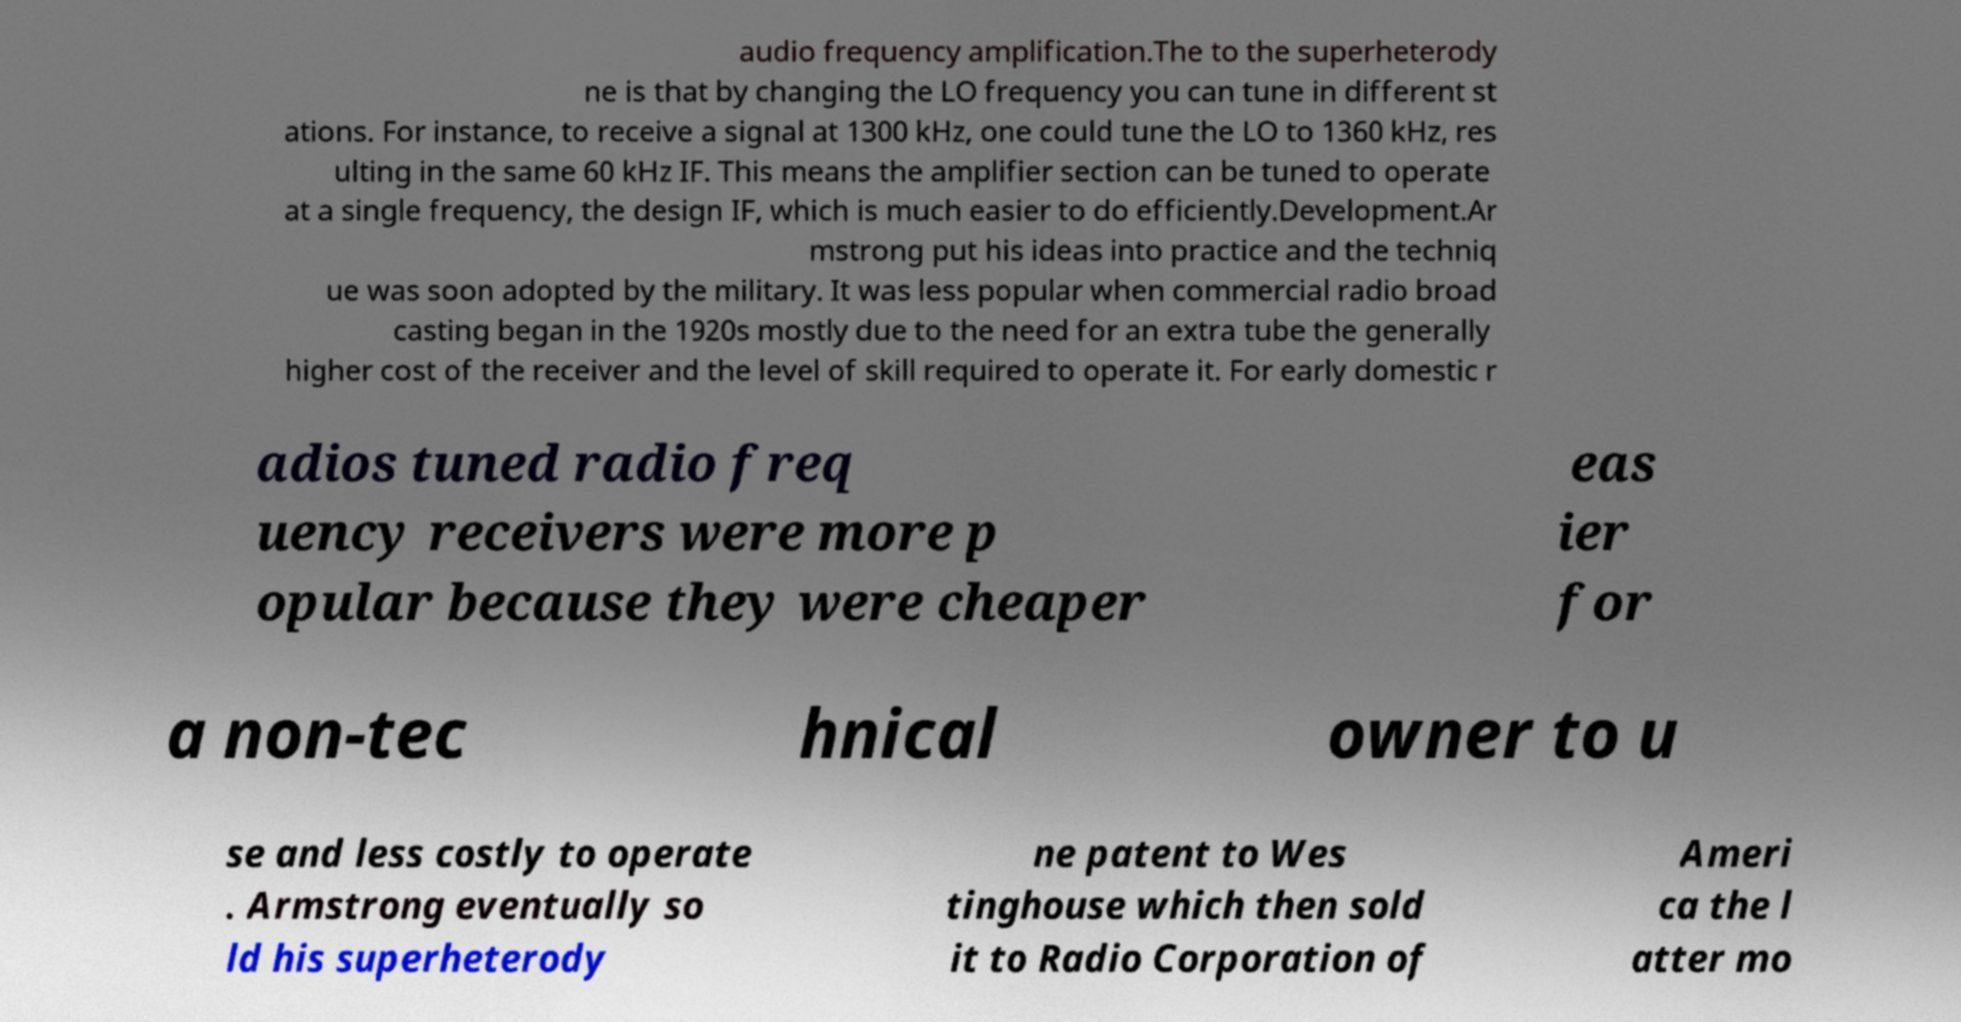Could you assist in decoding the text presented in this image and type it out clearly? audio frequency amplification.The to the superheterody ne is that by changing the LO frequency you can tune in different st ations. For instance, to receive a signal at 1300 kHz, one could tune the LO to 1360 kHz, res ulting in the same 60 kHz IF. This means the amplifier section can be tuned to operate at a single frequency, the design IF, which is much easier to do efficiently.Development.Ar mstrong put his ideas into practice and the techniq ue was soon adopted by the military. It was less popular when commercial radio broad casting began in the 1920s mostly due to the need for an extra tube the generally higher cost of the receiver and the level of skill required to operate it. For early domestic r adios tuned radio freq uency receivers were more p opular because they were cheaper eas ier for a non-tec hnical owner to u se and less costly to operate . Armstrong eventually so ld his superheterody ne patent to Wes tinghouse which then sold it to Radio Corporation of Ameri ca the l atter mo 